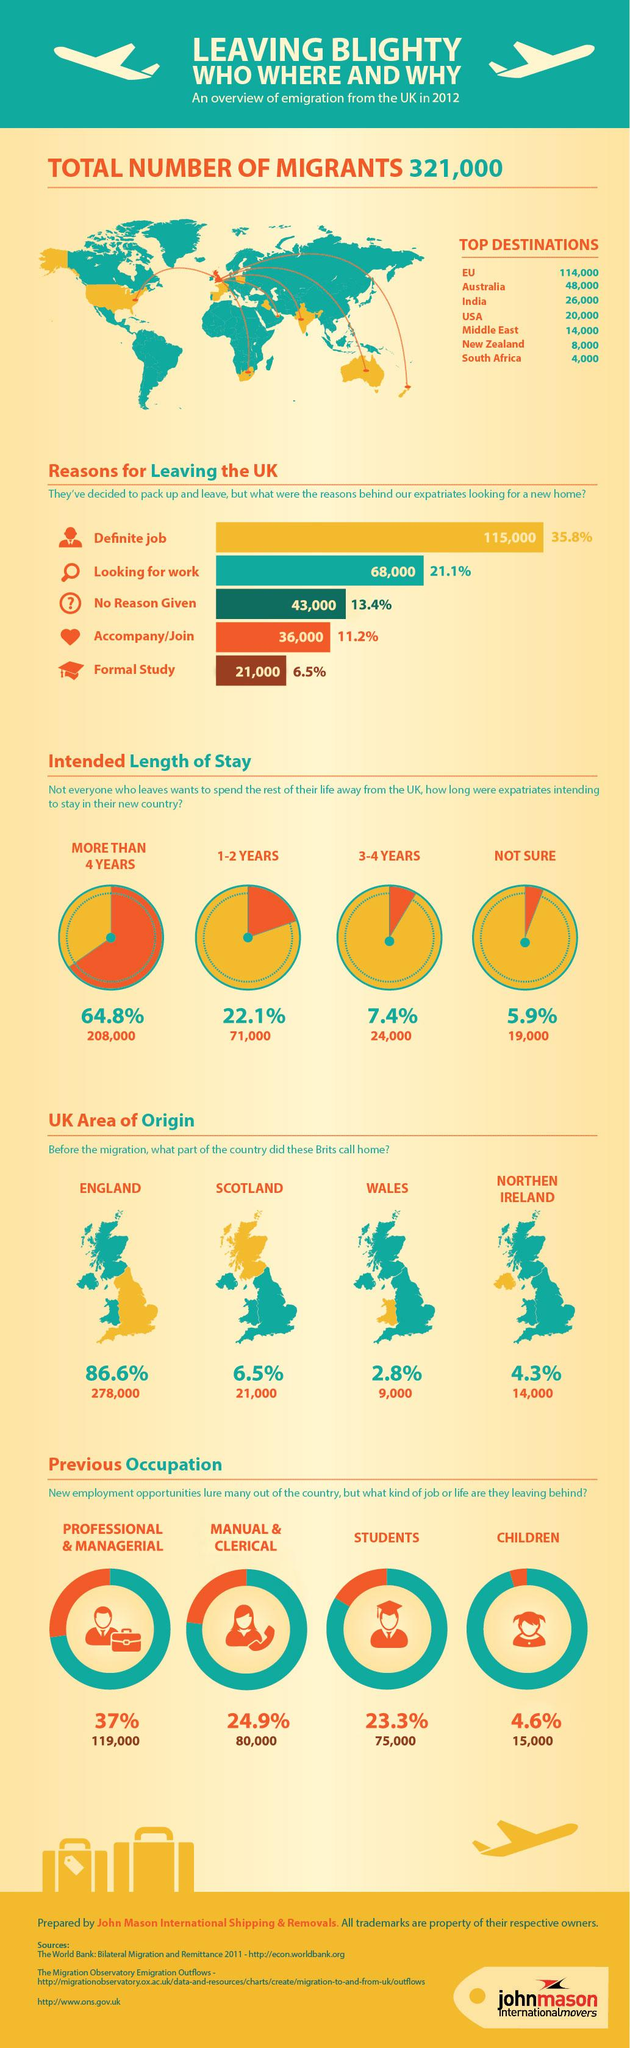List a handful of essential elements in this visual. The majority of migrants have migrated to the EU. New Zealand was the sixth most popular destination for migrants, according to the data. Most of them left the UK for a definite job. The second most common reason for expatriates to look for a new home is due to the search for work. The majority of these expatriates came from England before leaving their home country. 